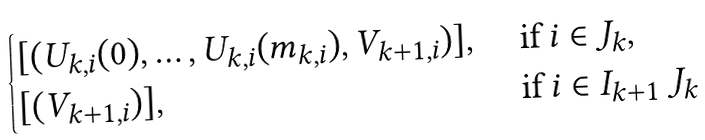Convert formula to latex. <formula><loc_0><loc_0><loc_500><loc_500>\begin{cases} [ ( U _ { k , i } ( 0 ) , \dots , U _ { k , i } ( m _ { k , i } ) , V _ { k + 1 , i } ) ] , \ & \text {if} \ i \in J _ { k } , \\ [ ( V _ { k + 1 , i } ) ] , \ & \text {if} \ i \in I _ { k + 1 } \ J _ { k } \end{cases}</formula> 